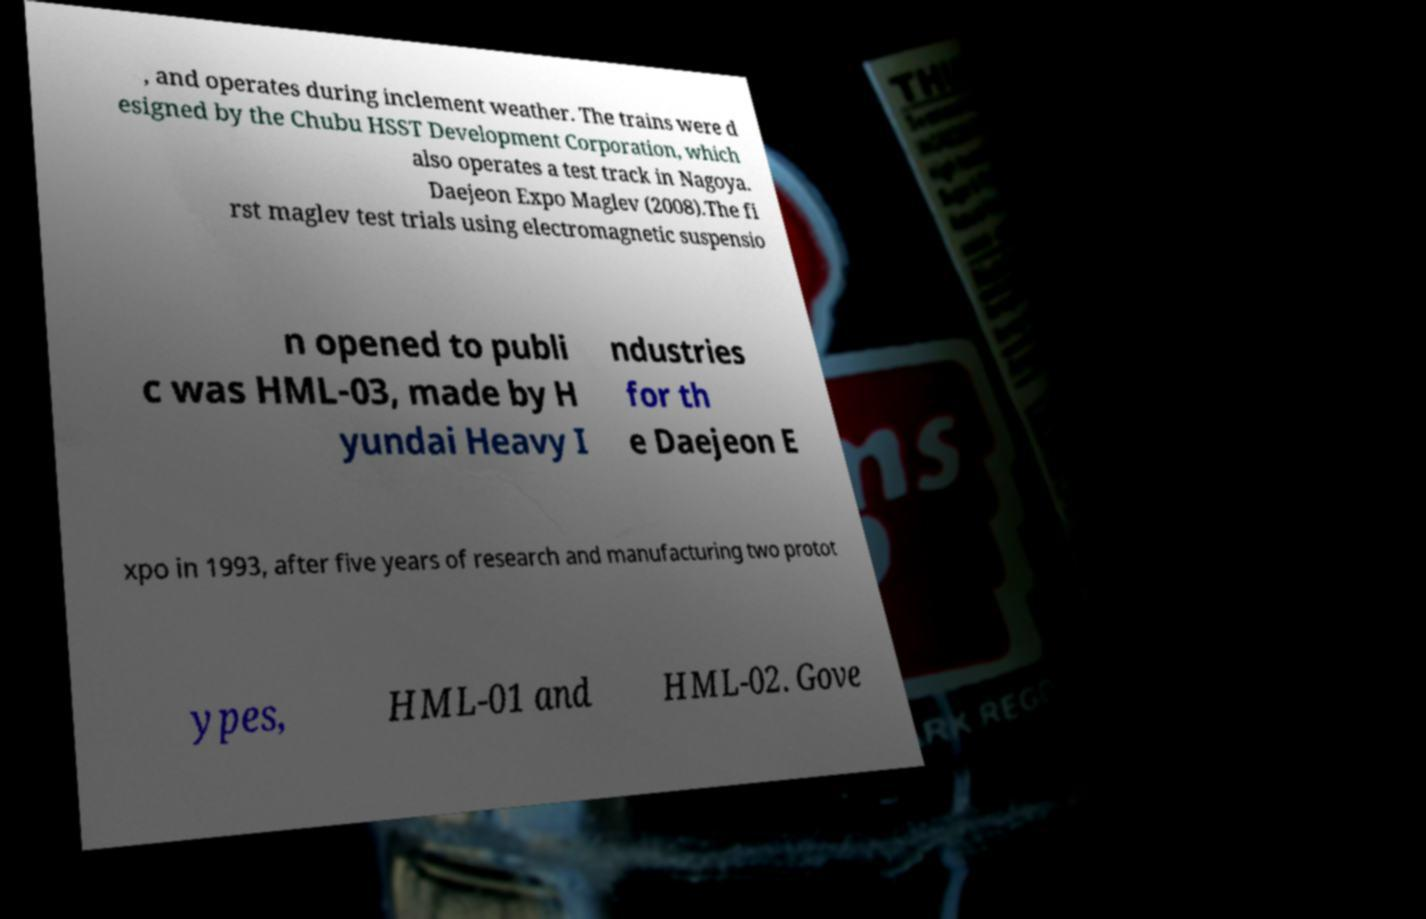Please read and relay the text visible in this image. What does it say? , and operates during inclement weather. The trains were d esigned by the Chubu HSST Development Corporation, which also operates a test track in Nagoya. Daejeon Expo Maglev (2008).The fi rst maglev test trials using electromagnetic suspensio n opened to publi c was HML-03, made by H yundai Heavy I ndustries for th e Daejeon E xpo in 1993, after five years of research and manufacturing two protot ypes, HML-01 and HML-02. Gove 